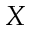<formula> <loc_0><loc_0><loc_500><loc_500>X</formula> 